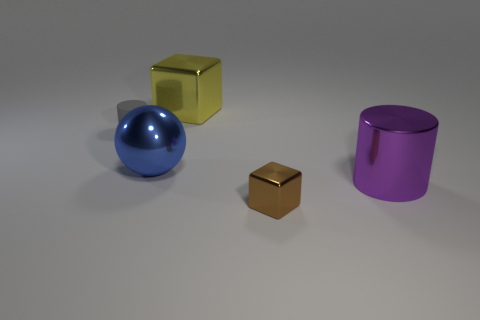Add 2 yellow shiny cylinders. How many objects exist? 7 Subtract all cylinders. How many objects are left? 3 Subtract all large yellow matte spheres. Subtract all tiny gray things. How many objects are left? 4 Add 4 purple things. How many purple things are left? 5 Add 2 metallic cylinders. How many metallic cylinders exist? 3 Subtract 0 green balls. How many objects are left? 5 